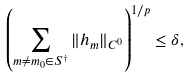Convert formula to latex. <formula><loc_0><loc_0><loc_500><loc_500>\left ( \sum _ { m \ne m _ { 0 } \in S ^ { \dagger } } \| h _ { m } \| _ { C ^ { 0 } } \right ) ^ { 1 / p } \leq \delta ,</formula> 